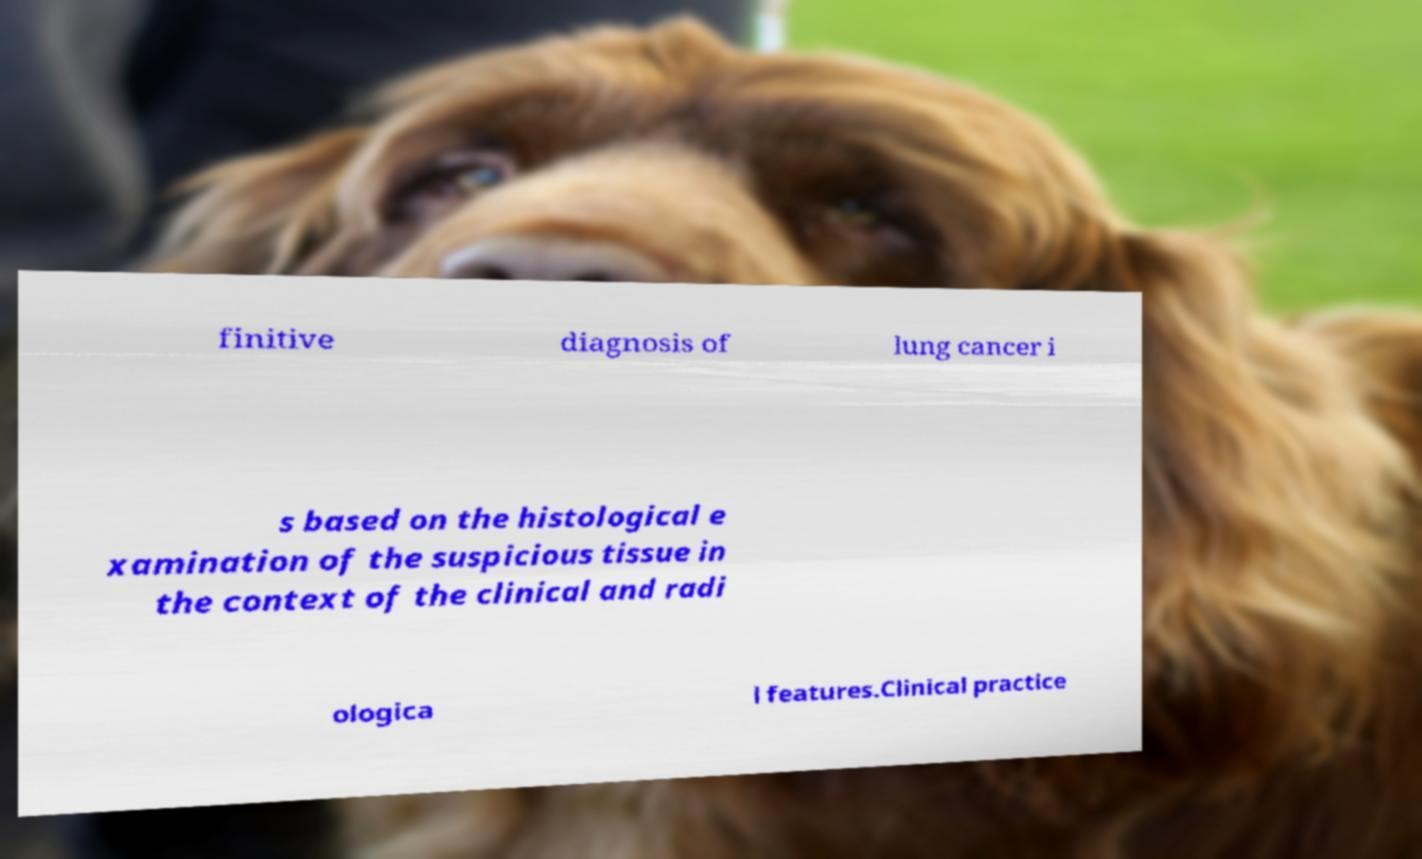Please identify and transcribe the text found in this image. finitive diagnosis of lung cancer i s based on the histological e xamination of the suspicious tissue in the context of the clinical and radi ologica l features.Clinical practice 